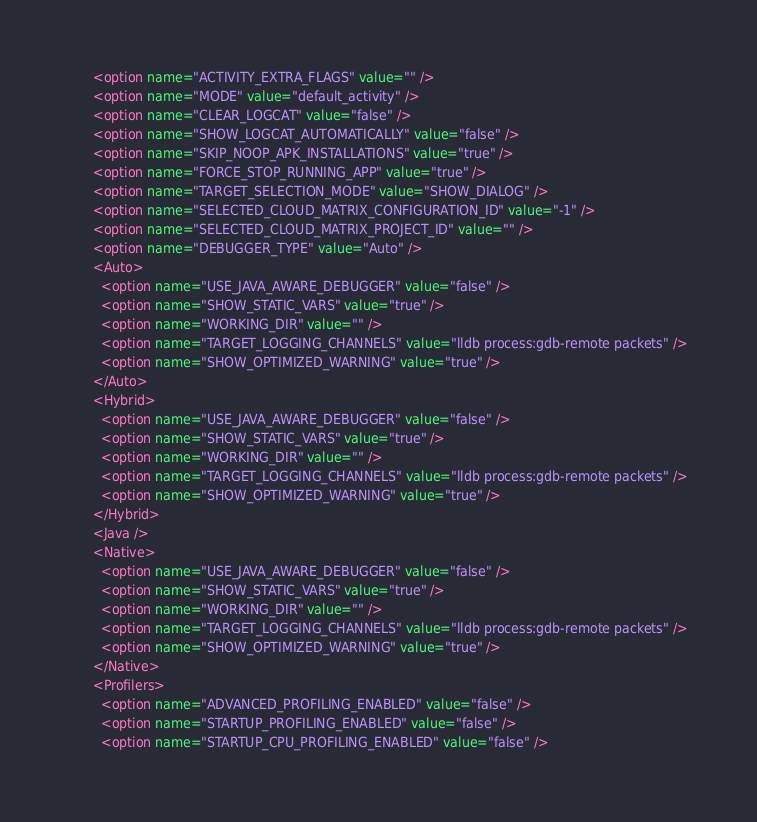<code> <loc_0><loc_0><loc_500><loc_500><_XML_>      <option name="ACTIVITY_EXTRA_FLAGS" value="" />
      <option name="MODE" value="default_activity" />
      <option name="CLEAR_LOGCAT" value="false" />
      <option name="SHOW_LOGCAT_AUTOMATICALLY" value="false" />
      <option name="SKIP_NOOP_APK_INSTALLATIONS" value="true" />
      <option name="FORCE_STOP_RUNNING_APP" value="true" />
      <option name="TARGET_SELECTION_MODE" value="SHOW_DIALOG" />
      <option name="SELECTED_CLOUD_MATRIX_CONFIGURATION_ID" value="-1" />
      <option name="SELECTED_CLOUD_MATRIX_PROJECT_ID" value="" />
      <option name="DEBUGGER_TYPE" value="Auto" />
      <Auto>
        <option name="USE_JAVA_AWARE_DEBUGGER" value="false" />
        <option name="SHOW_STATIC_VARS" value="true" />
        <option name="WORKING_DIR" value="" />
        <option name="TARGET_LOGGING_CHANNELS" value="lldb process:gdb-remote packets" />
        <option name="SHOW_OPTIMIZED_WARNING" value="true" />
      </Auto>
      <Hybrid>
        <option name="USE_JAVA_AWARE_DEBUGGER" value="false" />
        <option name="SHOW_STATIC_VARS" value="true" />
        <option name="WORKING_DIR" value="" />
        <option name="TARGET_LOGGING_CHANNELS" value="lldb process:gdb-remote packets" />
        <option name="SHOW_OPTIMIZED_WARNING" value="true" />
      </Hybrid>
      <Java />
      <Native>
        <option name="USE_JAVA_AWARE_DEBUGGER" value="false" />
        <option name="SHOW_STATIC_VARS" value="true" />
        <option name="WORKING_DIR" value="" />
        <option name="TARGET_LOGGING_CHANNELS" value="lldb process:gdb-remote packets" />
        <option name="SHOW_OPTIMIZED_WARNING" value="true" />
      </Native>
      <Profilers>
        <option name="ADVANCED_PROFILING_ENABLED" value="false" />
        <option name="STARTUP_PROFILING_ENABLED" value="false" />
        <option name="STARTUP_CPU_PROFILING_ENABLED" value="false" /></code> 